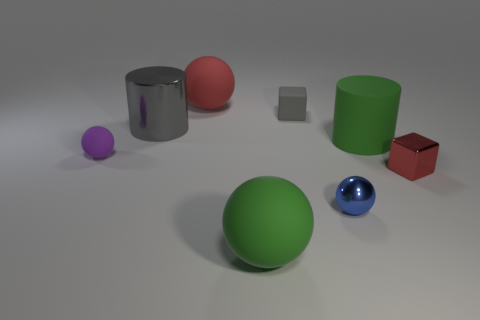Can you tell me the different colors of objects visible in this image? Certainly! This image displays objects in purple, red, light gray, dark gray, green, blue, and brown. Do the colors of these objects have any specific meaning or is it just a random assortment? In this context, the assortment of colors appears to be random, serving primarily to differentiate the objects and showcase a variety of materials and finishes. 